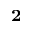Convert formula to latex. <formula><loc_0><loc_0><loc_500><loc_500>^ { 2 }</formula> 